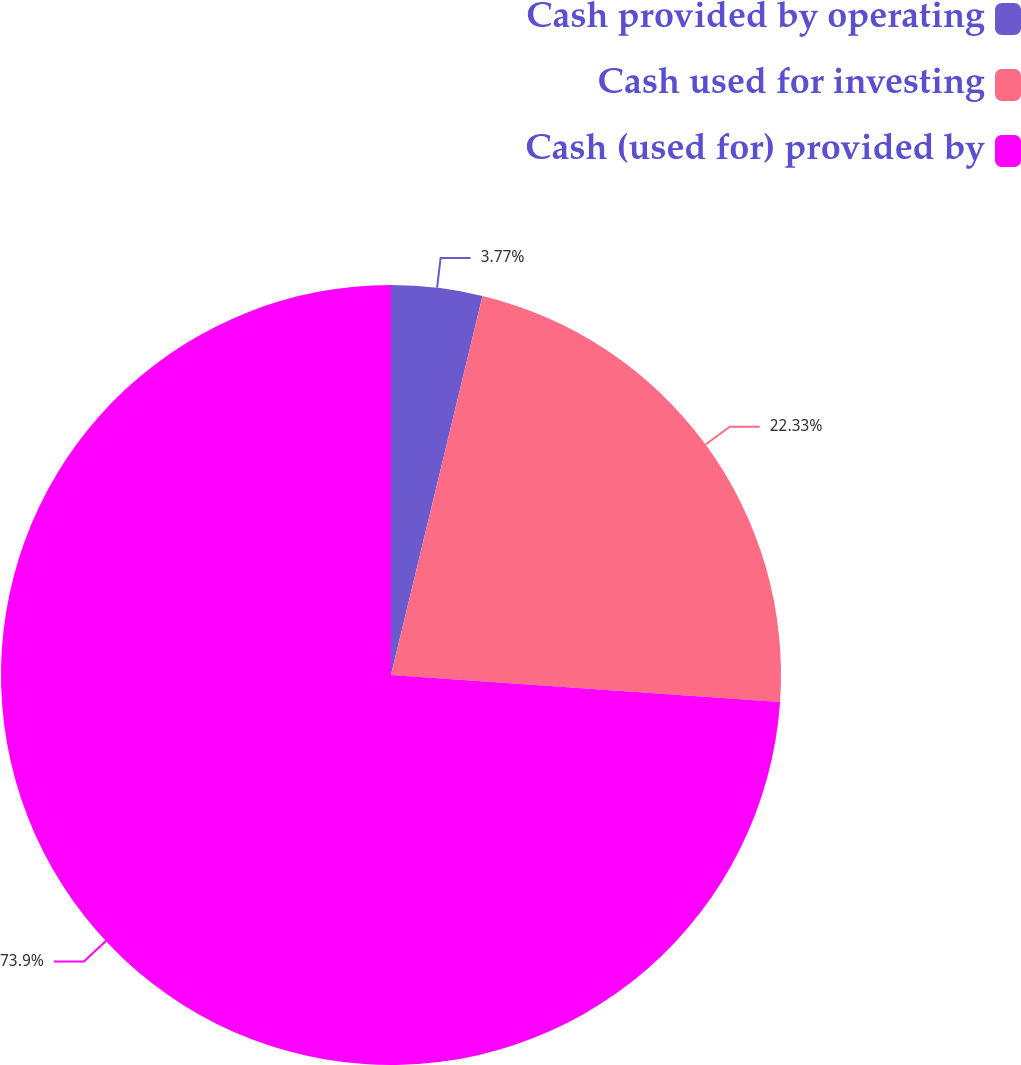<chart> <loc_0><loc_0><loc_500><loc_500><pie_chart><fcel>Cash provided by operating<fcel>Cash used for investing<fcel>Cash (used for) provided by<nl><fcel>3.77%<fcel>22.33%<fcel>73.9%<nl></chart> 